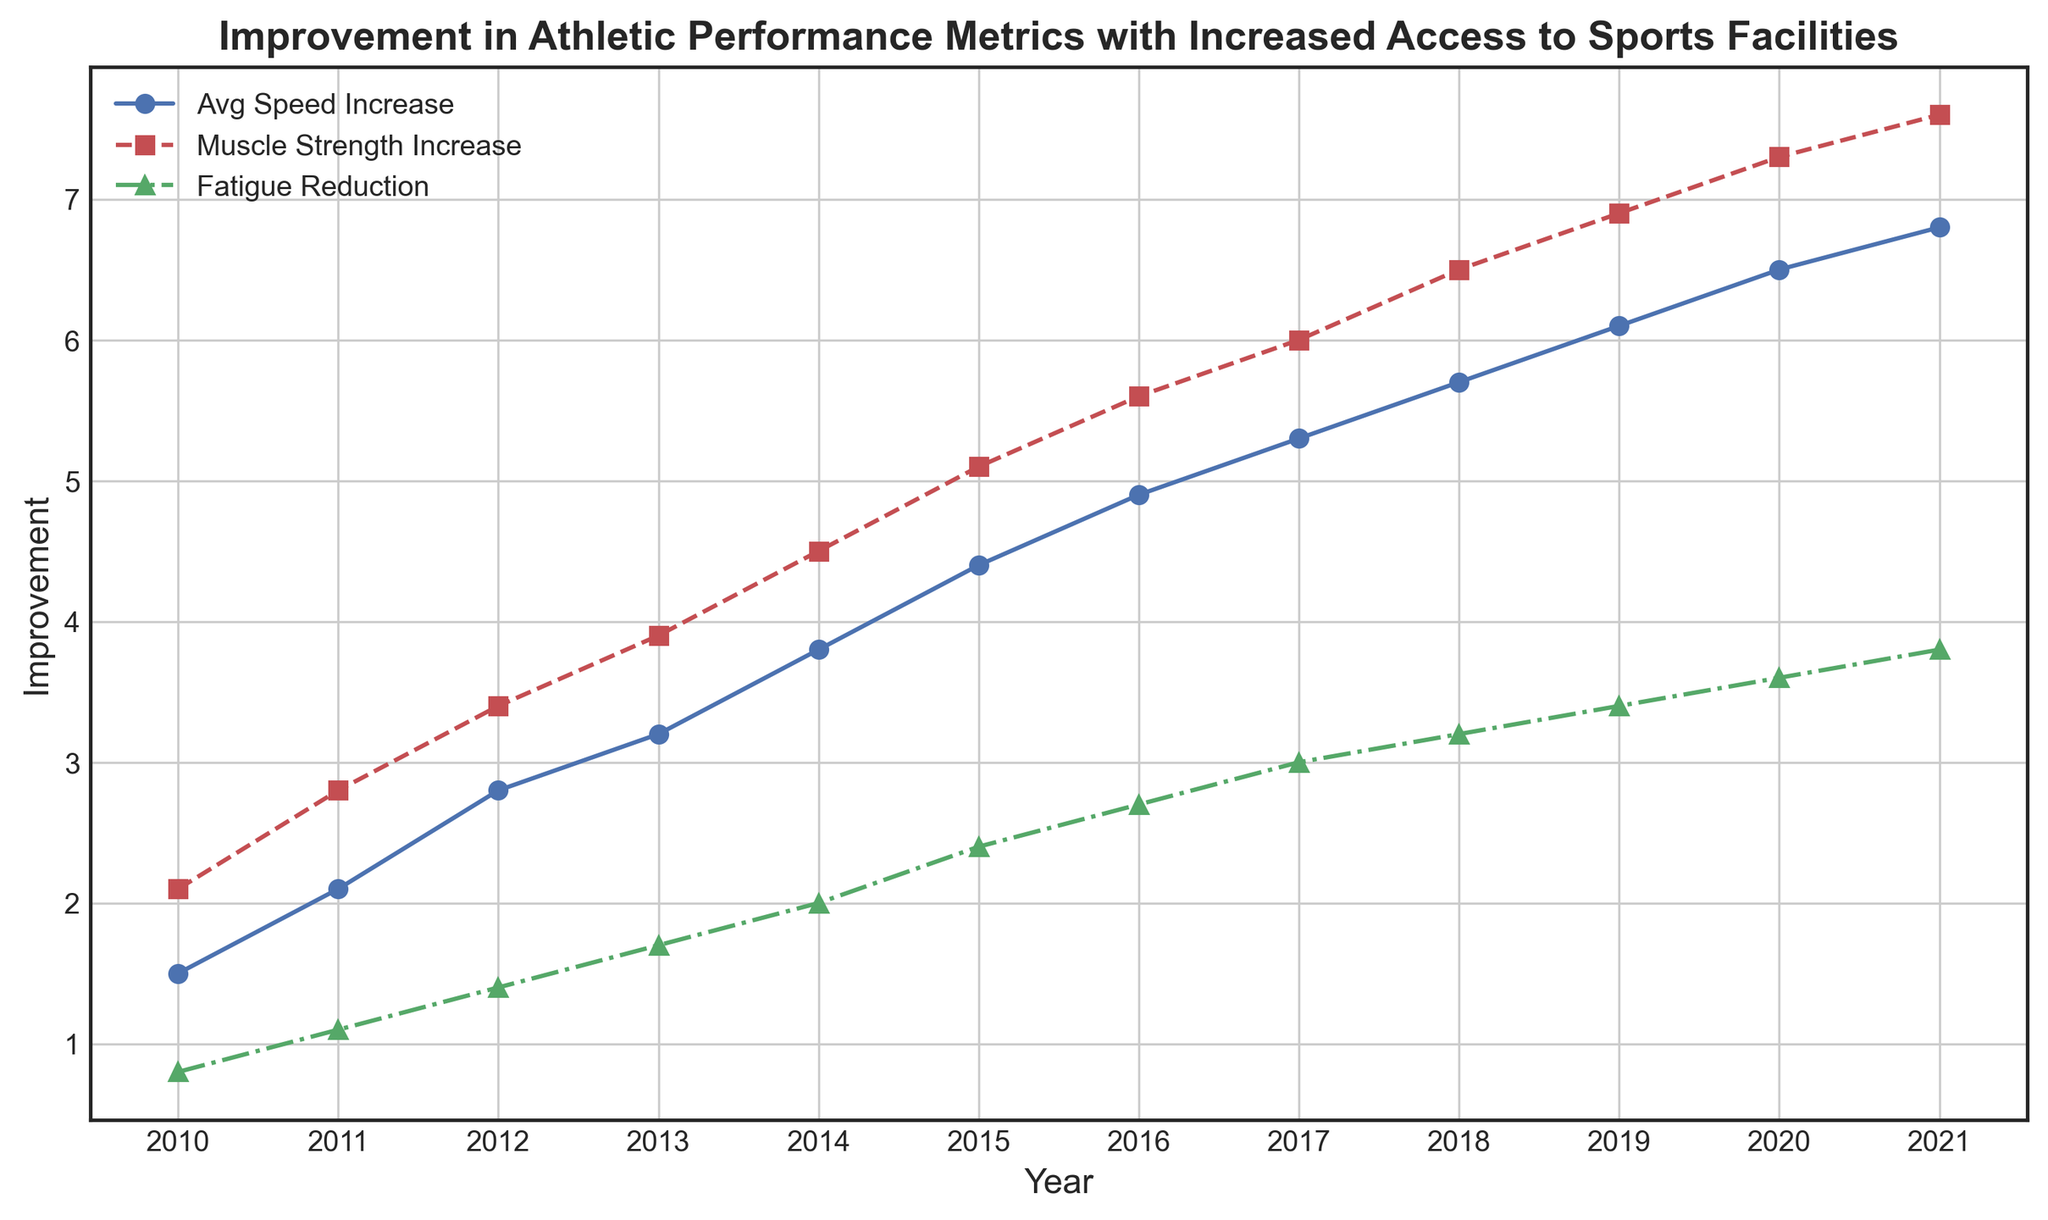What year shows the highest average speed increase? The chart shows the average speed increase by year. Find the highest point on the line labeled "Avg Speed Increase" and note the corresponding year on the x-axis.
Answer: 2021 Between 2015 and 2018, which year had the highest muscle strength increase? Look at the part of the chart between 2015 and 2018. Find the peak point on the line labeled "Muscle Strength Increase" in this range and note the corresponding year.
Answer: 2018 How much did fatigue reduction increase from 2012 to 2015? Find the points on the "Fatigue Reduction" line for the years 2012 and 2015. Subtract the 2012 value from the 2015 value. In 2012, it was 1.4, and in 2015 it was 2.4. Thus, 2.4 - 1.4 = 1.0
Answer: 1.0 In which year did the average speed increase surpass 4.0? Look for the year where the "Avg Speed Increase" line first crosses above the 4.0 mark on the y-axis. This happens between 2014 and 2015.
Answer: 2015 What is the difference in muscle strength increase between 2017 and 2019? Find the points on the "Muscle Strength Increase" line for 2017 and 2019. The values are 6.0 and 6.9 respectively. Subtract the 2017 value from the 2019 value. Thus, 6.9 - 6.0 = 0.9
Answer: 0.9 Which metric showed the greatest improvement in 2020? Look at the values for "Avg Speed Increase," "Muscle Strength Increase," and "Fatigue Reduction" for the year 2020. The metric with the highest value is the "Muscle Strength Increase" at 7.3.
Answer: Muscle Strength Increase Is the trend in fatigue reduction consistently increasing over the years? Examine the "Fatigue Reduction" line over all the years. The line increases every year, indicating a consistent upward trend.
Answer: Yes What is the average value of muscle strength increase from 2011 to 2013? Identify the values for "Muscle Strength Increase" from 2011 to 2013, which are 2.8, 3.4, and 3.9. Add these values and then divide by the number of years. (2.8 + 3.4 + 3.9) / 3 = 10.1 / 3 = 3.37
Answer: 3.37 How does the average speed increase in 2015 compare to the muscle strength increase in the same year? Check the values for "Avg Speed Increase" and "Muscle Strength Increase" in 2015. The "Avg Speed Increase" is 4.4 and the "Muscle Strength Increase" is 5.1. The muscle strength increase is higher.
Answer: Muscle Strength Increase is higher By how much did the average speed increase from 2010 to 2021? Find the values for "Avg Speed Increase" for 2010 and 2021. Subtract the 2010 value (1.5) from the 2021 value (6.8). Thus, 6.8 - 1.5 = 5.3
Answer: 5.3 